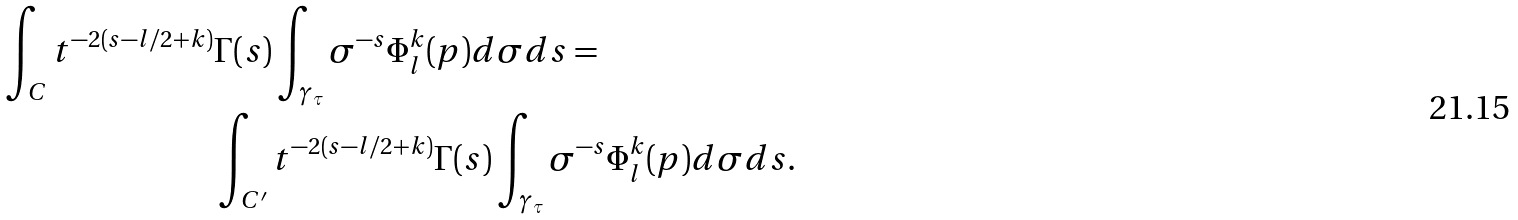<formula> <loc_0><loc_0><loc_500><loc_500>\int _ { C } t ^ { - 2 ( s - l / 2 + k ) } & \Gamma ( s ) \int _ { \gamma _ { \tau } } \sigma ^ { - s } \Phi _ { l } ^ { k } ( p ) d \sigma d s = \\ & \int _ { C ^ { \prime } } t ^ { - 2 ( s - l / 2 + k ) } \Gamma ( s ) \int _ { \gamma _ { \tau } } \sigma ^ { - s } \Phi _ { l } ^ { k } ( p ) d \sigma d s .</formula> 